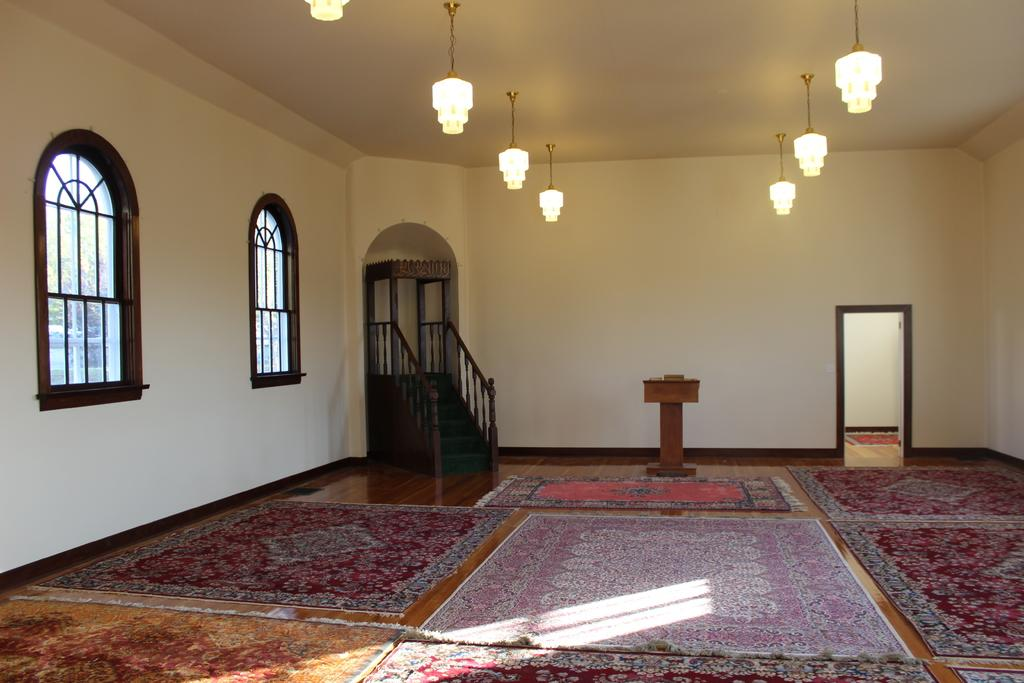What type of location might the image be taken in? The image might be taken in a room. What architectural feature can be seen in the image? There is a door in the image. What other feature can be seen in the image that might be used for moving between floors? There are stairs in the image. What can be seen in the image that allows natural light to enter the room? There are windows in the image. What can be seen in the image that provides illumination? There are lights in the image. What object can be seen in the image that might be used for presentations or speeches? There is a lectern in the image. What type of floor covering can be seen in the image? There are carpets in the image. How many zebras can be seen grazing on the carpets in the image? There are no zebras present in the image; it features a room with various architectural and interior design features. 